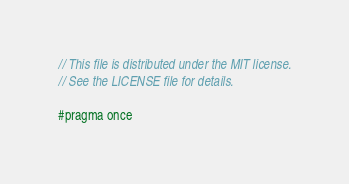Convert code to text. <code><loc_0><loc_0><loc_500><loc_500><_C_>// This file is distributed under the MIT license.
// See the LICENSE file for details.

#pragma once
</code> 